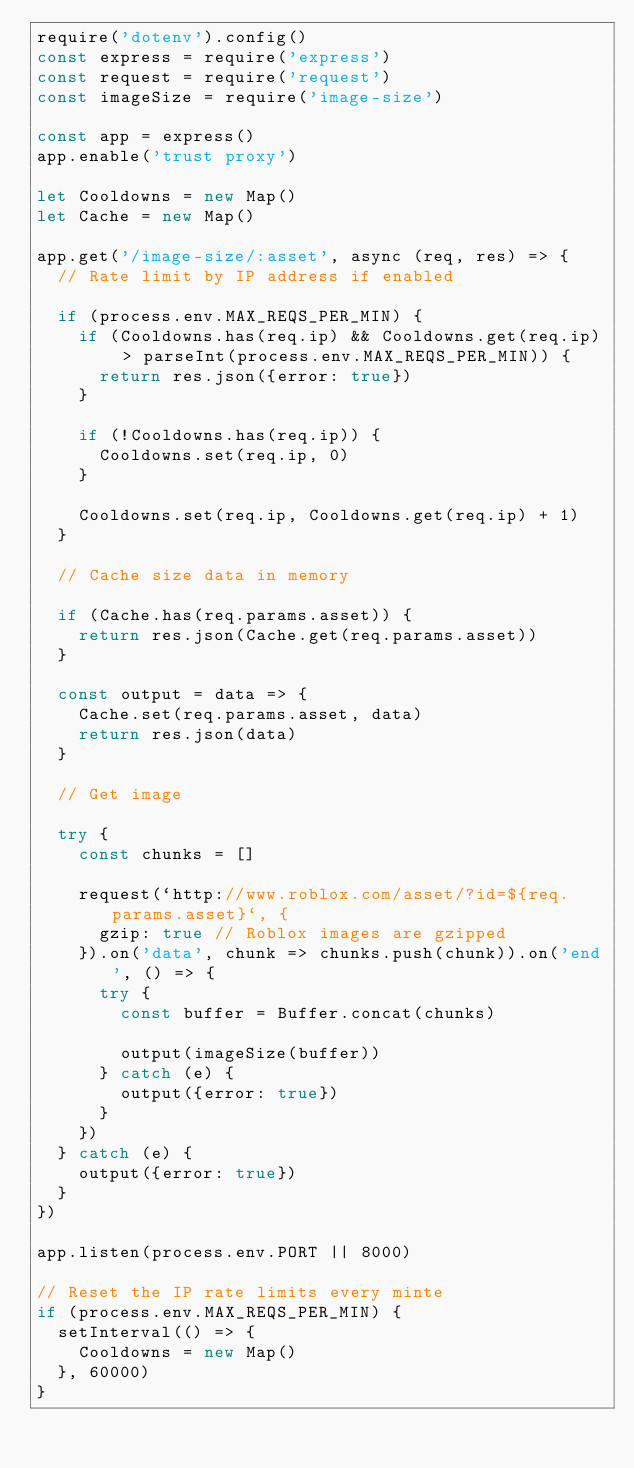Convert code to text. <code><loc_0><loc_0><loc_500><loc_500><_JavaScript_>require('dotenv').config()
const express = require('express')
const request = require('request')
const imageSize = require('image-size')

const app = express()
app.enable('trust proxy')

let Cooldowns = new Map()
let Cache = new Map()

app.get('/image-size/:asset', async (req, res) => {
  // Rate limit by IP address if enabled

  if (process.env.MAX_REQS_PER_MIN) {
    if (Cooldowns.has(req.ip) && Cooldowns.get(req.ip) > parseInt(process.env.MAX_REQS_PER_MIN)) {
      return res.json({error: true})
    }

    if (!Cooldowns.has(req.ip)) {
      Cooldowns.set(req.ip, 0)
    }

    Cooldowns.set(req.ip, Cooldowns.get(req.ip) + 1)
  }

  // Cache size data in memory

  if (Cache.has(req.params.asset)) {
    return res.json(Cache.get(req.params.asset))
  }

  const output = data => {
    Cache.set(req.params.asset, data)
    return res.json(data)
  }

  // Get image

  try {
    const chunks = []

    request(`http://www.roblox.com/asset/?id=${req.params.asset}`, {
      gzip: true // Roblox images are gzipped
    }).on('data', chunk => chunks.push(chunk)).on('end', () => {
      try {
        const buffer = Buffer.concat(chunks)

        output(imageSize(buffer))
      } catch (e) {
        output({error: true})
      }
    })
  } catch (e) {
    output({error: true})
  }
})

app.listen(process.env.PORT || 8000)

// Reset the IP rate limits every minte
if (process.env.MAX_REQS_PER_MIN) {
  setInterval(() => {
    Cooldowns = new Map()
  }, 60000)
}
</code> 